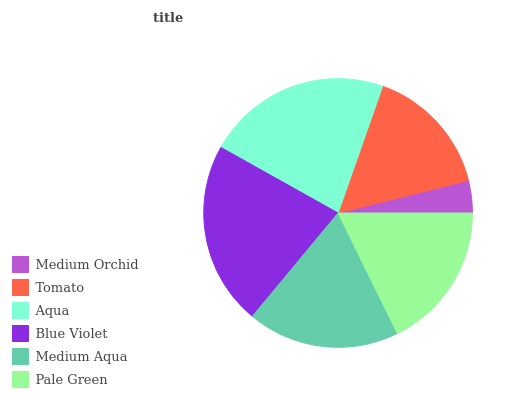Is Medium Orchid the minimum?
Answer yes or no. Yes. Is Aqua the maximum?
Answer yes or no. Yes. Is Tomato the minimum?
Answer yes or no. No. Is Tomato the maximum?
Answer yes or no. No. Is Tomato greater than Medium Orchid?
Answer yes or no. Yes. Is Medium Orchid less than Tomato?
Answer yes or no. Yes. Is Medium Orchid greater than Tomato?
Answer yes or no. No. Is Tomato less than Medium Orchid?
Answer yes or no. No. Is Medium Aqua the high median?
Answer yes or no. Yes. Is Pale Green the low median?
Answer yes or no. Yes. Is Tomato the high median?
Answer yes or no. No. Is Medium Aqua the low median?
Answer yes or no. No. 